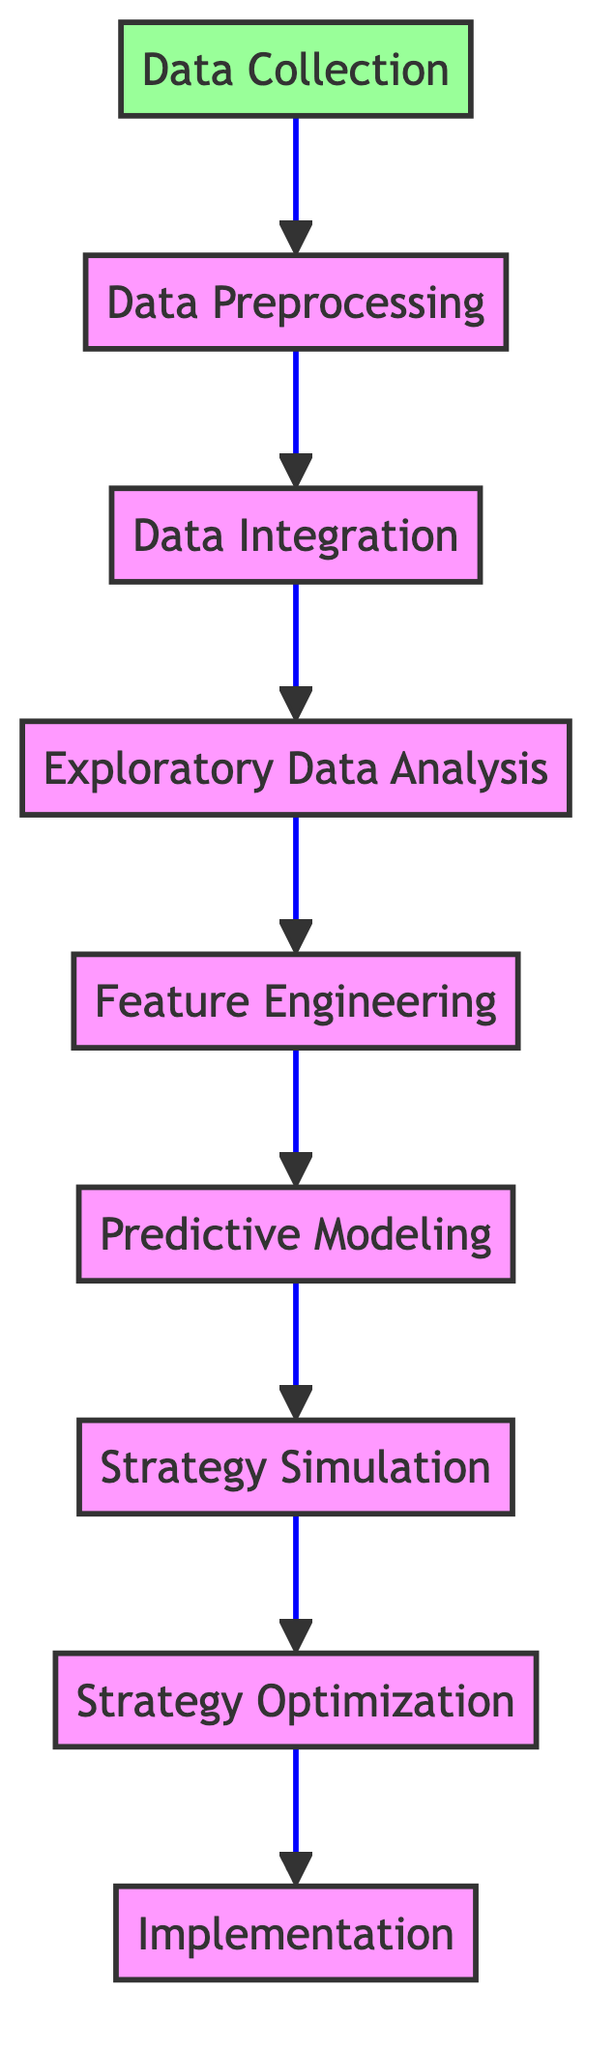What is the first step in the race strategy improvement process? The first step in the diagram is "Data Collection," which is located at the bottom of the flow chart.
Answer: Data Collection How many elements are present in the diagram? There are 9 elements in the diagram, representing different stages of the race strategy improvement process.
Answer: 9 What is the last step before implementation? The last step before implementation is "Strategy Optimization," which comes directly before the "Implementation" step at the top of the flow chart.
Answer: Strategy Optimization What process comes after exploratory data analysis? After "Exploratory Data Analysis," the next process is "Feature Engineering," which details the creation of new features for predictive modeling.
Answer: Feature Engineering Which two stages directly connect "Predictive Modeling"? The two stages that connect to "Predictive Modeling" are "Feature Engineering," which precedes it, and "Strategy Simulation," which follows it in the flow chart.
Answer: Feature Engineering and Strategy Simulation What type of analysis is performed in the fourth stage? The fourth stage is "Exploratory Data Analysis," which involves statistical analysis to identify patterns, trends, and anomalies within the data.
Answer: Exploratory Data Analysis Which stage involves executing the optimized strategy? The stage that involves executing the optimized strategy is "Implementation," positioned at the top of the flow chart.
Answer: Implementation What do "Data Preprocessing" and "Data Integration" have in common? Both "Data Preprocessing" and "Data Integration" are intermediary steps in organizing and preparing the collected data before analysis and modeling occur in the later stages.
Answer: They are intermediary steps in data preparation Which process simulates different race scenarios? The process that simulates different race scenarios is "Strategy Simulation," which allows for evaluating various strategies under diverse conditions.
Answer: Strategy Simulation 